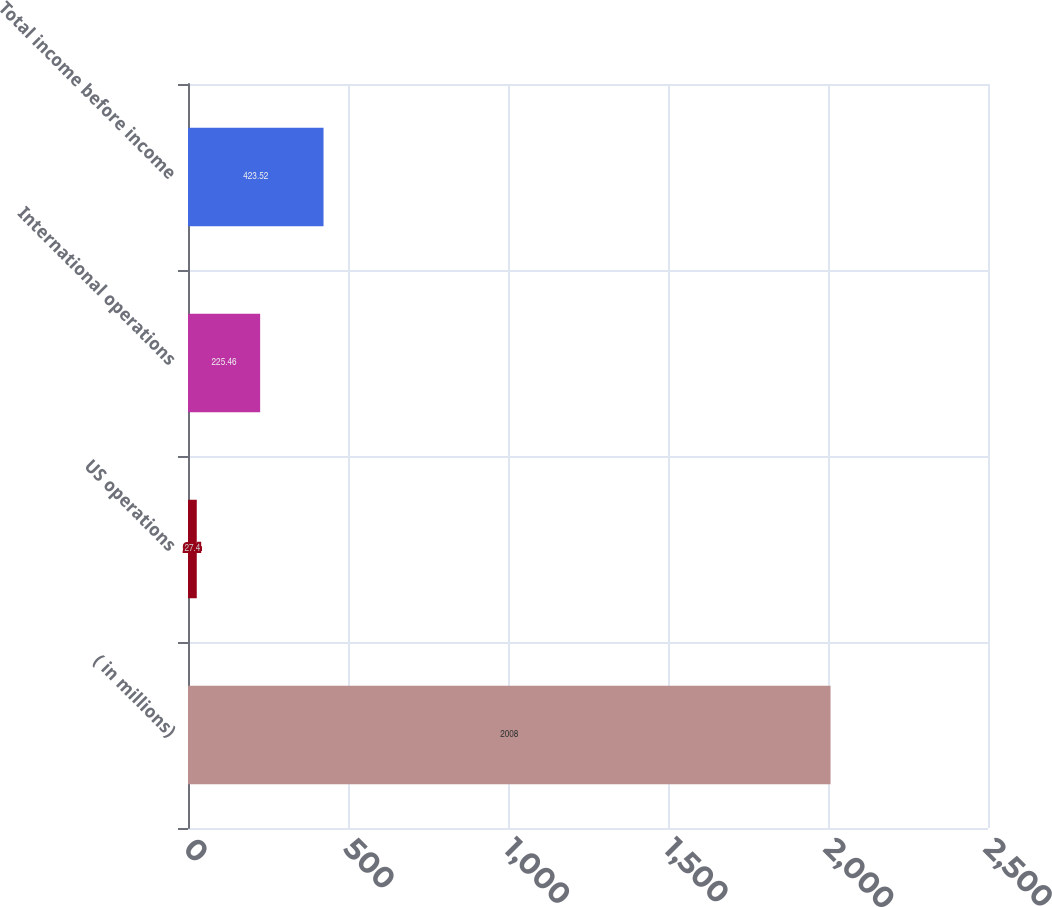Convert chart. <chart><loc_0><loc_0><loc_500><loc_500><bar_chart><fcel>( in millions)<fcel>US operations<fcel>International operations<fcel>Total income before income<nl><fcel>2008<fcel>27.4<fcel>225.46<fcel>423.52<nl></chart> 